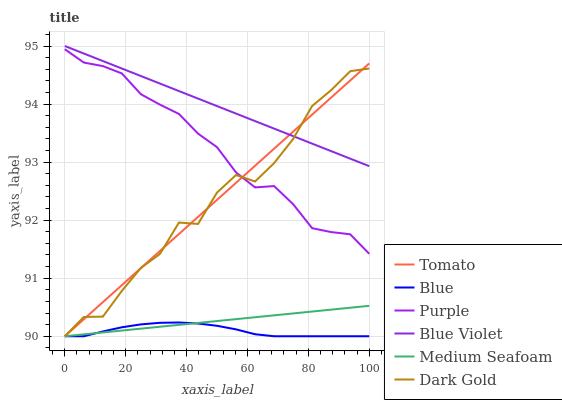Does Blue have the minimum area under the curve?
Answer yes or no. Yes. Does Blue Violet have the maximum area under the curve?
Answer yes or no. Yes. Does Dark Gold have the minimum area under the curve?
Answer yes or no. No. Does Dark Gold have the maximum area under the curve?
Answer yes or no. No. Is Medium Seafoam the smoothest?
Answer yes or no. Yes. Is Dark Gold the roughest?
Answer yes or no. Yes. Is Blue the smoothest?
Answer yes or no. No. Is Blue the roughest?
Answer yes or no. No. Does Tomato have the lowest value?
Answer yes or no. Yes. Does Purple have the lowest value?
Answer yes or no. No. Does Blue Violet have the highest value?
Answer yes or no. Yes. Does Dark Gold have the highest value?
Answer yes or no. No. Is Blue less than Blue Violet?
Answer yes or no. Yes. Is Purple greater than Medium Seafoam?
Answer yes or no. Yes. Does Purple intersect Tomato?
Answer yes or no. Yes. Is Purple less than Tomato?
Answer yes or no. No. Is Purple greater than Tomato?
Answer yes or no. No. Does Blue intersect Blue Violet?
Answer yes or no. No. 